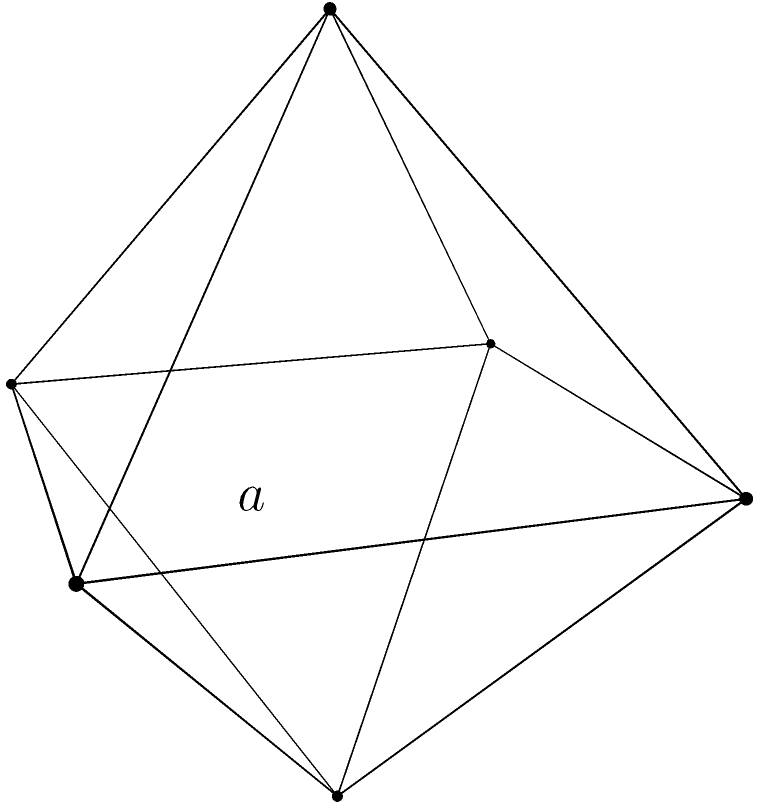In your research on syntactic anomalies, you're designing a 3D model of neural networks. The model takes the shape of a regular octahedron. If each edge of this octahedral model represents a neural pathway with length $a$, what is the total surface area of the model in terms of $a$? To find the surface area of a regular octahedron, we can follow these steps:

1) A regular octahedron consists of 8 equilateral triangular faces.

2) The surface area will be the sum of the areas of these 8 triangles.

3) For each triangular face:
   - The side length is $a$ (given edge length of the octahedron)
   - The area of an equilateral triangle with side $s$ is $\frac{\sqrt{3}}{4}s^2$

4) Area of one triangular face: $A_{face} = \frac{\sqrt{3}}{4}a^2$

5) Total surface area: $SA_{total} = 8 \times A_{face}$

6) Substituting and simplifying:
   $SA_{total} = 8 \times \frac{\sqrt{3}}{4}a^2 = 2\sqrt{3}a^2$

Therefore, the total surface area of the regular octahedral model is $2\sqrt{3}a^2$.
Answer: $2\sqrt{3}a^2$ 